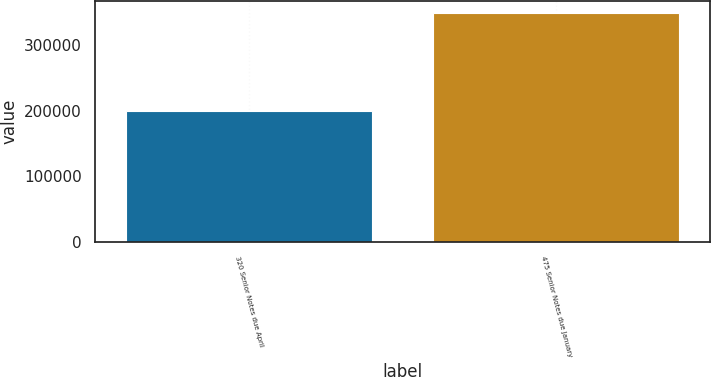Convert chart. <chart><loc_0><loc_0><loc_500><loc_500><bar_chart><fcel>320 Senior Notes due April<fcel>475 Senior Notes due January<nl><fcel>200000<fcel>350000<nl></chart> 